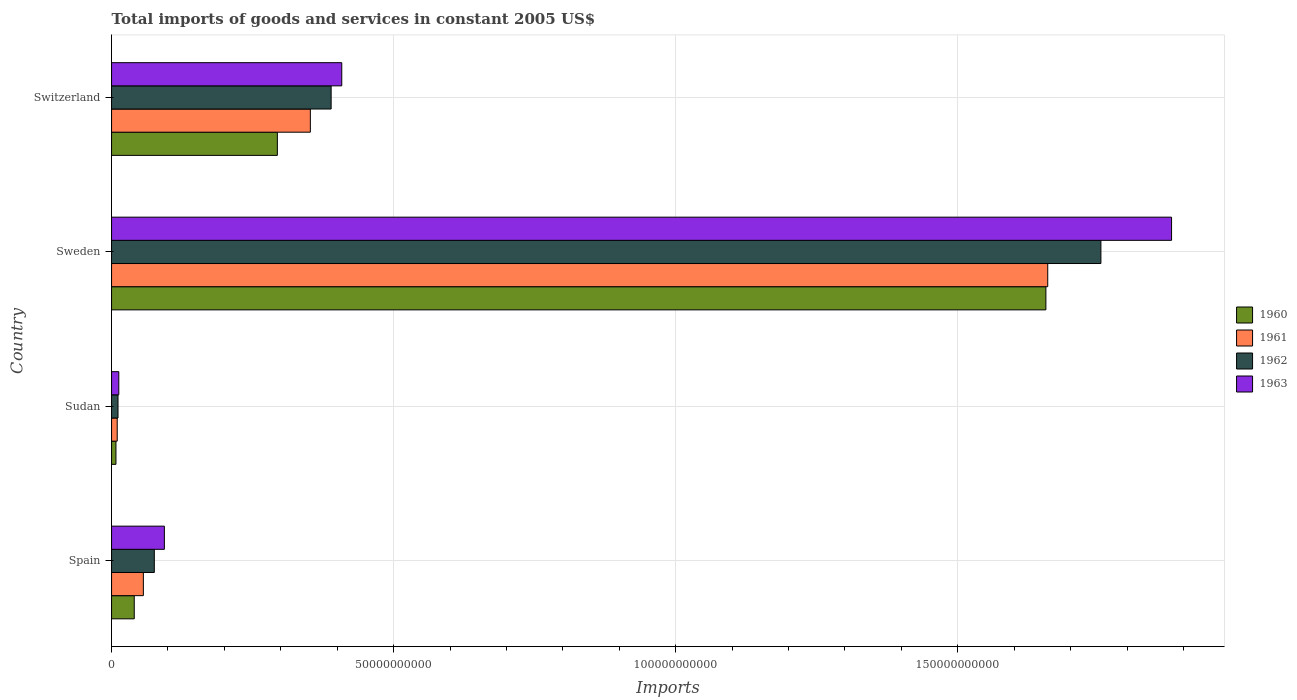Are the number of bars per tick equal to the number of legend labels?
Offer a very short reply. Yes. Are the number of bars on each tick of the Y-axis equal?
Ensure brevity in your answer.  Yes. How many bars are there on the 2nd tick from the bottom?
Your response must be concise. 4. What is the total imports of goods and services in 1962 in Sudan?
Your response must be concise. 1.14e+09. Across all countries, what is the maximum total imports of goods and services in 1963?
Offer a terse response. 1.88e+11. Across all countries, what is the minimum total imports of goods and services in 1962?
Give a very brief answer. 1.14e+09. In which country was the total imports of goods and services in 1962 maximum?
Ensure brevity in your answer.  Sweden. In which country was the total imports of goods and services in 1960 minimum?
Ensure brevity in your answer.  Sudan. What is the total total imports of goods and services in 1962 in the graph?
Your response must be concise. 2.23e+11. What is the difference between the total imports of goods and services in 1961 in Sudan and that in Sweden?
Provide a short and direct response. -1.65e+11. What is the difference between the total imports of goods and services in 1963 in Sudan and the total imports of goods and services in 1961 in Sweden?
Make the answer very short. -1.65e+11. What is the average total imports of goods and services in 1963 per country?
Make the answer very short. 5.98e+1. What is the difference between the total imports of goods and services in 1962 and total imports of goods and services in 1961 in Switzerland?
Your answer should be very brief. 3.69e+09. What is the ratio of the total imports of goods and services in 1963 in Spain to that in Sudan?
Ensure brevity in your answer.  7.3. Is the total imports of goods and services in 1961 in Spain less than that in Sudan?
Your response must be concise. No. Is the difference between the total imports of goods and services in 1962 in Sudan and Sweden greater than the difference between the total imports of goods and services in 1961 in Sudan and Sweden?
Your response must be concise. No. What is the difference between the highest and the second highest total imports of goods and services in 1961?
Offer a terse response. 1.31e+11. What is the difference between the highest and the lowest total imports of goods and services in 1960?
Offer a very short reply. 1.65e+11. In how many countries, is the total imports of goods and services in 1962 greater than the average total imports of goods and services in 1962 taken over all countries?
Your answer should be very brief. 1. Is it the case that in every country, the sum of the total imports of goods and services in 1960 and total imports of goods and services in 1962 is greater than the sum of total imports of goods and services in 1961 and total imports of goods and services in 1963?
Make the answer very short. No. What does the 4th bar from the bottom in Sudan represents?
Give a very brief answer. 1963. How many bars are there?
Provide a short and direct response. 16. Are all the bars in the graph horizontal?
Your answer should be very brief. Yes. How many countries are there in the graph?
Provide a short and direct response. 4. What is the difference between two consecutive major ticks on the X-axis?
Your response must be concise. 5.00e+1. Where does the legend appear in the graph?
Your response must be concise. Center right. How many legend labels are there?
Give a very brief answer. 4. How are the legend labels stacked?
Offer a terse response. Vertical. What is the title of the graph?
Provide a succinct answer. Total imports of goods and services in constant 2005 US$. What is the label or title of the X-axis?
Your response must be concise. Imports. What is the label or title of the Y-axis?
Offer a terse response. Country. What is the Imports of 1960 in Spain?
Keep it short and to the point. 4.02e+09. What is the Imports of 1961 in Spain?
Give a very brief answer. 5.64e+09. What is the Imports of 1962 in Spain?
Offer a very short reply. 7.58e+09. What is the Imports of 1963 in Spain?
Your answer should be compact. 9.36e+09. What is the Imports of 1960 in Sudan?
Your response must be concise. 7.79e+08. What is the Imports in 1961 in Sudan?
Ensure brevity in your answer.  1.00e+09. What is the Imports in 1962 in Sudan?
Give a very brief answer. 1.14e+09. What is the Imports in 1963 in Sudan?
Offer a very short reply. 1.28e+09. What is the Imports in 1960 in Sweden?
Offer a terse response. 1.66e+11. What is the Imports in 1961 in Sweden?
Your answer should be compact. 1.66e+11. What is the Imports of 1962 in Sweden?
Keep it short and to the point. 1.75e+11. What is the Imports in 1963 in Sweden?
Offer a very short reply. 1.88e+11. What is the Imports of 1960 in Switzerland?
Your answer should be compact. 2.94e+1. What is the Imports of 1961 in Switzerland?
Your answer should be very brief. 3.52e+1. What is the Imports of 1962 in Switzerland?
Your answer should be compact. 3.89e+1. What is the Imports of 1963 in Switzerland?
Your answer should be very brief. 4.08e+1. Across all countries, what is the maximum Imports of 1960?
Give a very brief answer. 1.66e+11. Across all countries, what is the maximum Imports of 1961?
Offer a very short reply. 1.66e+11. Across all countries, what is the maximum Imports of 1962?
Offer a very short reply. 1.75e+11. Across all countries, what is the maximum Imports of 1963?
Provide a short and direct response. 1.88e+11. Across all countries, what is the minimum Imports of 1960?
Offer a terse response. 7.79e+08. Across all countries, what is the minimum Imports of 1961?
Make the answer very short. 1.00e+09. Across all countries, what is the minimum Imports of 1962?
Make the answer very short. 1.14e+09. Across all countries, what is the minimum Imports in 1963?
Your answer should be compact. 1.28e+09. What is the total Imports in 1960 in the graph?
Your answer should be compact. 2.00e+11. What is the total Imports of 1961 in the graph?
Offer a terse response. 2.08e+11. What is the total Imports of 1962 in the graph?
Offer a very short reply. 2.23e+11. What is the total Imports in 1963 in the graph?
Your response must be concise. 2.39e+11. What is the difference between the Imports of 1960 in Spain and that in Sudan?
Your answer should be very brief. 3.24e+09. What is the difference between the Imports of 1961 in Spain and that in Sudan?
Your answer should be very brief. 4.63e+09. What is the difference between the Imports in 1962 in Spain and that in Sudan?
Offer a terse response. 6.44e+09. What is the difference between the Imports of 1963 in Spain and that in Sudan?
Provide a succinct answer. 8.08e+09. What is the difference between the Imports in 1960 in Spain and that in Sweden?
Ensure brevity in your answer.  -1.62e+11. What is the difference between the Imports in 1961 in Spain and that in Sweden?
Offer a terse response. -1.60e+11. What is the difference between the Imports of 1962 in Spain and that in Sweden?
Offer a very short reply. -1.68e+11. What is the difference between the Imports of 1963 in Spain and that in Sweden?
Your answer should be compact. -1.79e+11. What is the difference between the Imports of 1960 in Spain and that in Switzerland?
Offer a terse response. -2.54e+1. What is the difference between the Imports in 1961 in Spain and that in Switzerland?
Keep it short and to the point. -2.96e+1. What is the difference between the Imports of 1962 in Spain and that in Switzerland?
Your answer should be very brief. -3.13e+1. What is the difference between the Imports of 1963 in Spain and that in Switzerland?
Ensure brevity in your answer.  -3.14e+1. What is the difference between the Imports of 1960 in Sudan and that in Sweden?
Offer a very short reply. -1.65e+11. What is the difference between the Imports of 1961 in Sudan and that in Sweden?
Provide a succinct answer. -1.65e+11. What is the difference between the Imports of 1962 in Sudan and that in Sweden?
Give a very brief answer. -1.74e+11. What is the difference between the Imports of 1963 in Sudan and that in Sweden?
Make the answer very short. -1.87e+11. What is the difference between the Imports of 1960 in Sudan and that in Switzerland?
Provide a short and direct response. -2.86e+1. What is the difference between the Imports of 1961 in Sudan and that in Switzerland?
Provide a succinct answer. -3.42e+1. What is the difference between the Imports in 1962 in Sudan and that in Switzerland?
Your response must be concise. -3.78e+1. What is the difference between the Imports in 1963 in Sudan and that in Switzerland?
Provide a short and direct response. -3.95e+1. What is the difference between the Imports in 1960 in Sweden and that in Switzerland?
Make the answer very short. 1.36e+11. What is the difference between the Imports in 1961 in Sweden and that in Switzerland?
Your answer should be very brief. 1.31e+11. What is the difference between the Imports in 1962 in Sweden and that in Switzerland?
Make the answer very short. 1.36e+11. What is the difference between the Imports of 1963 in Sweden and that in Switzerland?
Your response must be concise. 1.47e+11. What is the difference between the Imports of 1960 in Spain and the Imports of 1961 in Sudan?
Provide a succinct answer. 3.02e+09. What is the difference between the Imports of 1960 in Spain and the Imports of 1962 in Sudan?
Offer a terse response. 2.88e+09. What is the difference between the Imports in 1960 in Spain and the Imports in 1963 in Sudan?
Offer a terse response. 2.74e+09. What is the difference between the Imports in 1961 in Spain and the Imports in 1962 in Sudan?
Offer a very short reply. 4.49e+09. What is the difference between the Imports of 1961 in Spain and the Imports of 1963 in Sudan?
Provide a succinct answer. 4.35e+09. What is the difference between the Imports in 1962 in Spain and the Imports in 1963 in Sudan?
Offer a terse response. 6.30e+09. What is the difference between the Imports of 1960 in Spain and the Imports of 1961 in Sweden?
Your answer should be very brief. -1.62e+11. What is the difference between the Imports in 1960 in Spain and the Imports in 1962 in Sweden?
Give a very brief answer. -1.71e+11. What is the difference between the Imports in 1960 in Spain and the Imports in 1963 in Sweden?
Make the answer very short. -1.84e+11. What is the difference between the Imports of 1961 in Spain and the Imports of 1962 in Sweden?
Give a very brief answer. -1.70e+11. What is the difference between the Imports in 1961 in Spain and the Imports in 1963 in Sweden?
Keep it short and to the point. -1.82e+11. What is the difference between the Imports in 1962 in Spain and the Imports in 1963 in Sweden?
Keep it short and to the point. -1.80e+11. What is the difference between the Imports of 1960 in Spain and the Imports of 1961 in Switzerland?
Keep it short and to the point. -3.12e+1. What is the difference between the Imports of 1960 in Spain and the Imports of 1962 in Switzerland?
Ensure brevity in your answer.  -3.49e+1. What is the difference between the Imports in 1960 in Spain and the Imports in 1963 in Switzerland?
Your answer should be very brief. -3.68e+1. What is the difference between the Imports of 1961 in Spain and the Imports of 1962 in Switzerland?
Provide a short and direct response. -3.33e+1. What is the difference between the Imports in 1961 in Spain and the Imports in 1963 in Switzerland?
Keep it short and to the point. -3.52e+1. What is the difference between the Imports in 1962 in Spain and the Imports in 1963 in Switzerland?
Keep it short and to the point. -3.32e+1. What is the difference between the Imports in 1960 in Sudan and the Imports in 1961 in Sweden?
Provide a short and direct response. -1.65e+11. What is the difference between the Imports in 1960 in Sudan and the Imports in 1962 in Sweden?
Ensure brevity in your answer.  -1.75e+11. What is the difference between the Imports in 1960 in Sudan and the Imports in 1963 in Sweden?
Offer a very short reply. -1.87e+11. What is the difference between the Imports in 1961 in Sudan and the Imports in 1962 in Sweden?
Provide a short and direct response. -1.74e+11. What is the difference between the Imports of 1961 in Sudan and the Imports of 1963 in Sweden?
Provide a short and direct response. -1.87e+11. What is the difference between the Imports in 1962 in Sudan and the Imports in 1963 in Sweden?
Keep it short and to the point. -1.87e+11. What is the difference between the Imports of 1960 in Sudan and the Imports of 1961 in Switzerland?
Ensure brevity in your answer.  -3.45e+1. What is the difference between the Imports in 1960 in Sudan and the Imports in 1962 in Switzerland?
Keep it short and to the point. -3.81e+1. What is the difference between the Imports of 1960 in Sudan and the Imports of 1963 in Switzerland?
Provide a succinct answer. -4.00e+1. What is the difference between the Imports of 1961 in Sudan and the Imports of 1962 in Switzerland?
Keep it short and to the point. -3.79e+1. What is the difference between the Imports in 1961 in Sudan and the Imports in 1963 in Switzerland?
Offer a terse response. -3.98e+1. What is the difference between the Imports in 1962 in Sudan and the Imports in 1963 in Switzerland?
Your answer should be compact. -3.97e+1. What is the difference between the Imports of 1960 in Sweden and the Imports of 1961 in Switzerland?
Ensure brevity in your answer.  1.30e+11. What is the difference between the Imports in 1960 in Sweden and the Imports in 1962 in Switzerland?
Provide a short and direct response. 1.27e+11. What is the difference between the Imports of 1960 in Sweden and the Imports of 1963 in Switzerland?
Ensure brevity in your answer.  1.25e+11. What is the difference between the Imports of 1961 in Sweden and the Imports of 1962 in Switzerland?
Provide a short and direct response. 1.27e+11. What is the difference between the Imports in 1961 in Sweden and the Imports in 1963 in Switzerland?
Make the answer very short. 1.25e+11. What is the difference between the Imports in 1962 in Sweden and the Imports in 1963 in Switzerland?
Your answer should be compact. 1.35e+11. What is the average Imports of 1960 per country?
Make the answer very short. 5.00e+1. What is the average Imports of 1961 per country?
Your response must be concise. 5.20e+1. What is the average Imports of 1962 per country?
Offer a very short reply. 5.58e+1. What is the average Imports in 1963 per country?
Your answer should be very brief. 5.98e+1. What is the difference between the Imports of 1960 and Imports of 1961 in Spain?
Offer a terse response. -1.61e+09. What is the difference between the Imports of 1960 and Imports of 1962 in Spain?
Your answer should be compact. -3.56e+09. What is the difference between the Imports of 1960 and Imports of 1963 in Spain?
Provide a succinct answer. -5.34e+09. What is the difference between the Imports in 1961 and Imports in 1962 in Spain?
Provide a short and direct response. -1.94e+09. What is the difference between the Imports in 1961 and Imports in 1963 in Spain?
Your answer should be very brief. -3.72e+09. What is the difference between the Imports of 1962 and Imports of 1963 in Spain?
Keep it short and to the point. -1.78e+09. What is the difference between the Imports of 1960 and Imports of 1961 in Sudan?
Give a very brief answer. -2.25e+08. What is the difference between the Imports of 1960 and Imports of 1962 in Sudan?
Keep it short and to the point. -3.65e+08. What is the difference between the Imports in 1960 and Imports in 1963 in Sudan?
Keep it short and to the point. -5.04e+08. What is the difference between the Imports of 1961 and Imports of 1962 in Sudan?
Make the answer very short. -1.39e+08. What is the difference between the Imports in 1961 and Imports in 1963 in Sudan?
Your response must be concise. -2.79e+08. What is the difference between the Imports in 1962 and Imports in 1963 in Sudan?
Your answer should be compact. -1.39e+08. What is the difference between the Imports in 1960 and Imports in 1961 in Sweden?
Keep it short and to the point. -3.29e+08. What is the difference between the Imports of 1960 and Imports of 1962 in Sweden?
Your response must be concise. -9.75e+09. What is the difference between the Imports in 1960 and Imports in 1963 in Sweden?
Give a very brief answer. -2.23e+1. What is the difference between the Imports in 1961 and Imports in 1962 in Sweden?
Your answer should be very brief. -9.42e+09. What is the difference between the Imports in 1961 and Imports in 1963 in Sweden?
Your answer should be very brief. -2.19e+1. What is the difference between the Imports of 1962 and Imports of 1963 in Sweden?
Offer a terse response. -1.25e+1. What is the difference between the Imports in 1960 and Imports in 1961 in Switzerland?
Give a very brief answer. -5.85e+09. What is the difference between the Imports of 1960 and Imports of 1962 in Switzerland?
Offer a very short reply. -9.53e+09. What is the difference between the Imports of 1960 and Imports of 1963 in Switzerland?
Your answer should be very brief. -1.14e+1. What is the difference between the Imports in 1961 and Imports in 1962 in Switzerland?
Offer a terse response. -3.69e+09. What is the difference between the Imports in 1961 and Imports in 1963 in Switzerland?
Ensure brevity in your answer.  -5.57e+09. What is the difference between the Imports of 1962 and Imports of 1963 in Switzerland?
Make the answer very short. -1.88e+09. What is the ratio of the Imports in 1960 in Spain to that in Sudan?
Your answer should be compact. 5.16. What is the ratio of the Imports of 1961 in Spain to that in Sudan?
Offer a terse response. 5.61. What is the ratio of the Imports of 1962 in Spain to that in Sudan?
Provide a short and direct response. 6.63. What is the ratio of the Imports in 1963 in Spain to that in Sudan?
Offer a terse response. 7.3. What is the ratio of the Imports of 1960 in Spain to that in Sweden?
Offer a terse response. 0.02. What is the ratio of the Imports in 1961 in Spain to that in Sweden?
Keep it short and to the point. 0.03. What is the ratio of the Imports of 1962 in Spain to that in Sweden?
Provide a short and direct response. 0.04. What is the ratio of the Imports of 1963 in Spain to that in Sweden?
Keep it short and to the point. 0.05. What is the ratio of the Imports of 1960 in Spain to that in Switzerland?
Provide a short and direct response. 0.14. What is the ratio of the Imports of 1961 in Spain to that in Switzerland?
Ensure brevity in your answer.  0.16. What is the ratio of the Imports of 1962 in Spain to that in Switzerland?
Your response must be concise. 0.19. What is the ratio of the Imports of 1963 in Spain to that in Switzerland?
Keep it short and to the point. 0.23. What is the ratio of the Imports in 1960 in Sudan to that in Sweden?
Make the answer very short. 0. What is the ratio of the Imports in 1961 in Sudan to that in Sweden?
Make the answer very short. 0.01. What is the ratio of the Imports in 1962 in Sudan to that in Sweden?
Your response must be concise. 0.01. What is the ratio of the Imports in 1963 in Sudan to that in Sweden?
Give a very brief answer. 0.01. What is the ratio of the Imports in 1960 in Sudan to that in Switzerland?
Provide a short and direct response. 0.03. What is the ratio of the Imports in 1961 in Sudan to that in Switzerland?
Offer a very short reply. 0.03. What is the ratio of the Imports in 1962 in Sudan to that in Switzerland?
Give a very brief answer. 0.03. What is the ratio of the Imports in 1963 in Sudan to that in Switzerland?
Offer a terse response. 0.03. What is the ratio of the Imports in 1960 in Sweden to that in Switzerland?
Offer a very short reply. 5.64. What is the ratio of the Imports of 1961 in Sweden to that in Switzerland?
Your answer should be compact. 4.71. What is the ratio of the Imports of 1962 in Sweden to that in Switzerland?
Your response must be concise. 4.51. What is the ratio of the Imports in 1963 in Sweden to that in Switzerland?
Your answer should be compact. 4.6. What is the difference between the highest and the second highest Imports of 1960?
Give a very brief answer. 1.36e+11. What is the difference between the highest and the second highest Imports of 1961?
Keep it short and to the point. 1.31e+11. What is the difference between the highest and the second highest Imports of 1962?
Offer a very short reply. 1.36e+11. What is the difference between the highest and the second highest Imports in 1963?
Your answer should be very brief. 1.47e+11. What is the difference between the highest and the lowest Imports of 1960?
Make the answer very short. 1.65e+11. What is the difference between the highest and the lowest Imports of 1961?
Your response must be concise. 1.65e+11. What is the difference between the highest and the lowest Imports in 1962?
Your answer should be very brief. 1.74e+11. What is the difference between the highest and the lowest Imports of 1963?
Keep it short and to the point. 1.87e+11. 